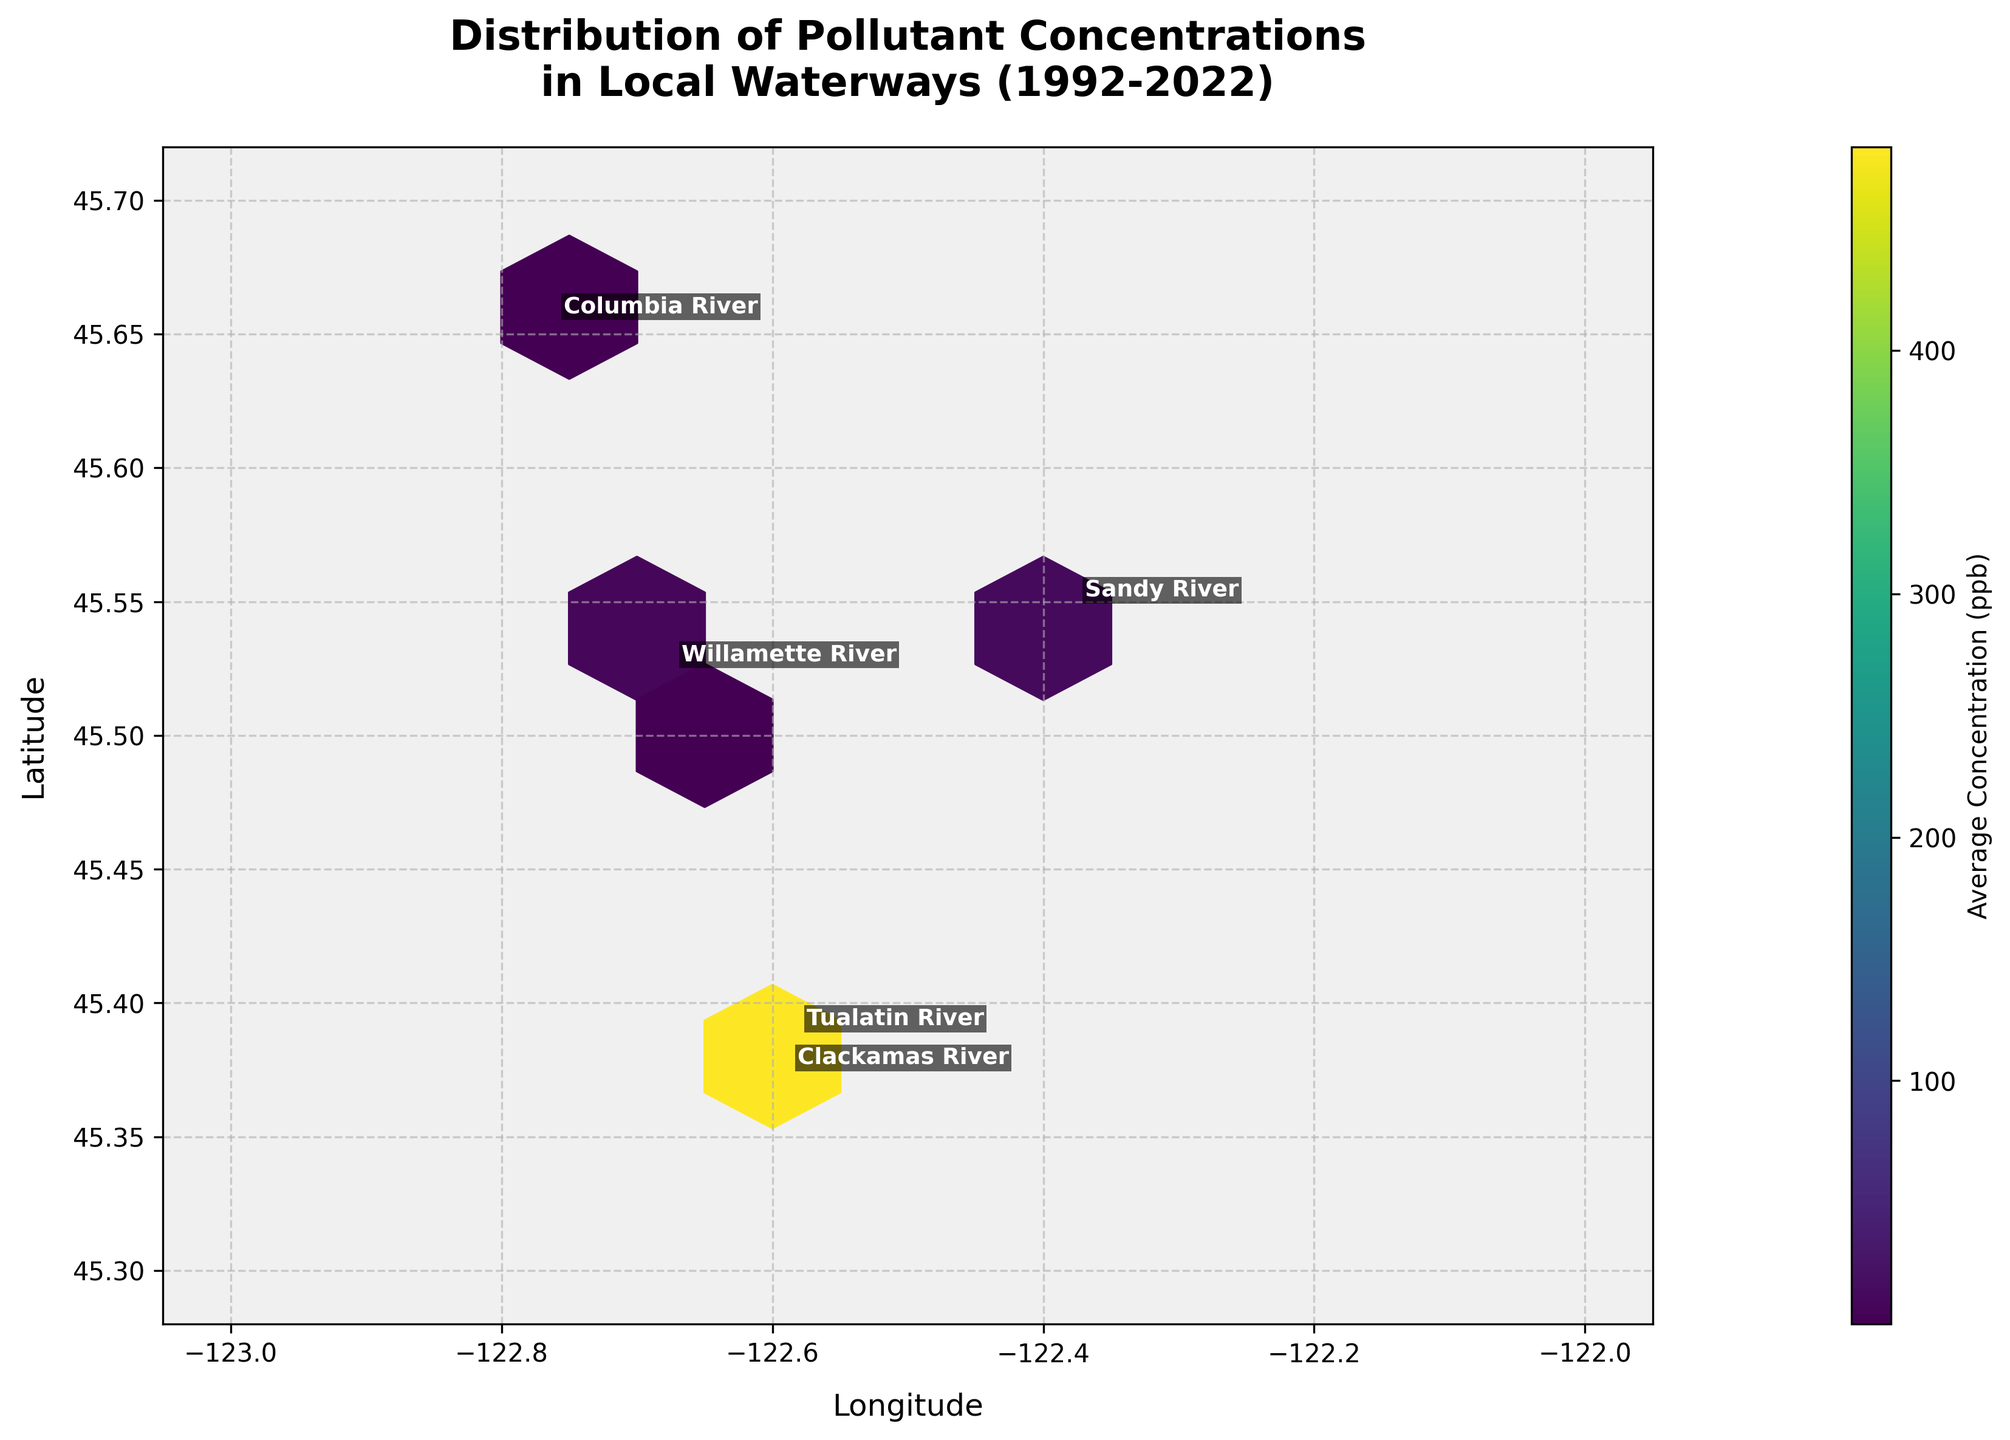What's the full title of the hexbin plot? The title is located at the top of the figure and describes what the plot represents.
Answer: Distribution of Pollutant Concentrations in Local Waterways (1992-2022) What are the axis labels in the figure? The labels are found along the horizontal and vertical axes and describe what each axis represents.
Answer: Longitude and Latitude What color represents higher average concentration in the plot? In the figure, there is a color bar to the right that indicates what colors represent higher or lower concentrations.
Answer: Brighter colors (closer to yellow) How many unique waterways are labeled in the figure? Each unique waterway is annotated on the figure; count these annotations to find the total number.
Answer: Five Which waterway has the highest level of pollutant concentration? By looking at the color bar and the brightest hexagons on the plot, identify which waterway annotation is closest to these hexagons.
Answer: Clackamas River What's the average pollutant concentration around the longitude of -122.7 and latitude of 45.65? Locate this region on the plot and refer to the color bar to estimate the average concentration denoted by the color in that area.
Answer: Approximately 0.5 ppb Which two waterways have the closest geographical coordinates? Compare the annotated locations of the waterways on the map to determine which two are situated closest to each other.
Answer: Clackamas River and Tualatin River Is there a noticeable concentration difference between the longitudes of -123 and -122.3? Observe the variations in color (intensity) along the longitudes to compare pollutant concentration differences.
Answer: Yes What's the average pollutant concentration across the plot? Estimate the average color intensity based on the color bar and interpolate this visually across the entire plot.
Answer: Approximately 200 ppb How does the concentration vary between the north and south parts of the plot? Compare the color intensities of hexbin cells located in the northern versus the southern sections of the figure.
Answer: Concentrations appear higher in the north 